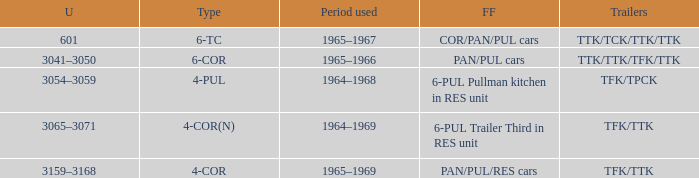Name the formed that has type of 4-cor PAN/PUL/RES cars. 